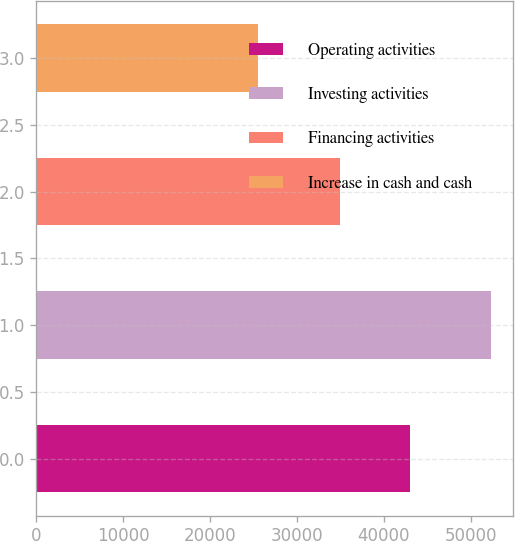<chart> <loc_0><loc_0><loc_500><loc_500><bar_chart><fcel>Operating activities<fcel>Investing activities<fcel>Financing activities<fcel>Increase in cash and cash<nl><fcel>42972<fcel>52324<fcel>34922<fcel>25570<nl></chart> 